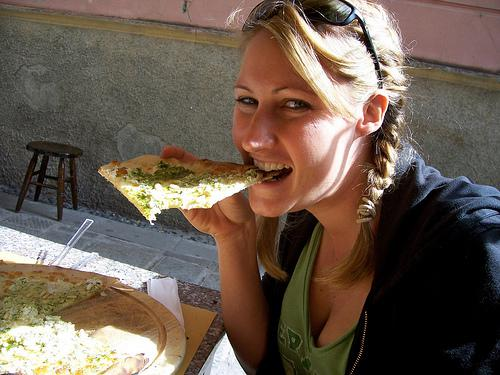Question: what is the woman eating?
Choices:
A. French fries.
B. Sandwich.
C. Pizza.
D. Ice cream.
Answer with the letter. Answer: C Question: what hairstyle is this?
Choices:
A. Ponytail.
B. Braided pigtails.
C. French braid.
D. Curled.
Answer with the letter. Answer: B Question: where are the sunglasses?
Choices:
A. On the woman's head.
B. On the table.
C. On the wamon's face.
D. In the case.
Answer with the letter. Answer: A Question: how is the weather?
Choices:
A. Cloudy.
B. Sunny.
C. Rainy.
D. Snowy.
Answer with the letter. Answer: B 